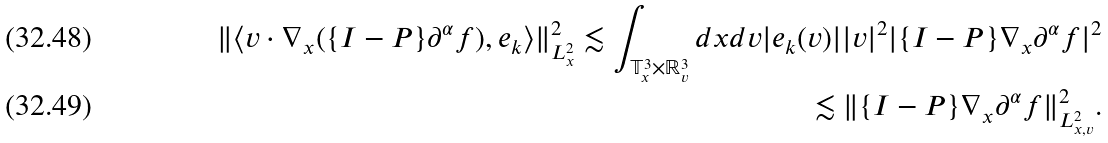<formula> <loc_0><loc_0><loc_500><loc_500>\| \langle v \cdot \nabla _ { x } ( \{ { I - P } \} \partial ^ { \alpha } f ) , e _ { k } \rangle \| _ { L ^ { 2 } _ { x } } ^ { 2 } \lesssim \int _ { \mathbb { T } ^ { 3 } _ { x } \times \mathbb { R } _ { v } ^ { 3 } } d x d v | e _ { k } ( v ) | | v | ^ { 2 } | \{ { I - P } \} \nabla _ { x } \partial ^ { \alpha } f | ^ { 2 } \\ \lesssim \| \{ { I - P } \} \nabla _ { x } \partial ^ { \alpha } f \| ^ { 2 } _ { L ^ { 2 } _ { x , v } } .</formula> 